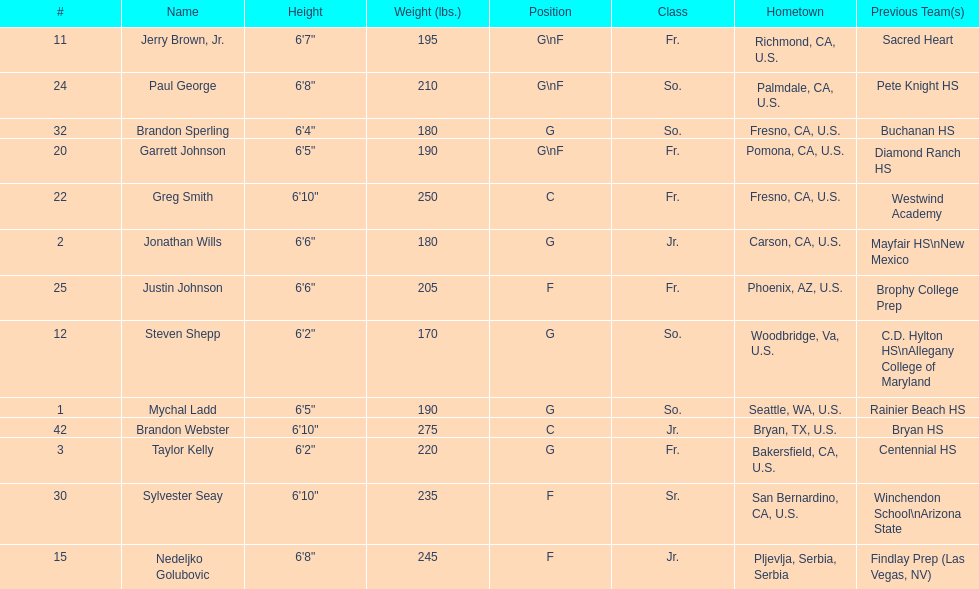How many players hometowns are outside of california? 5. 